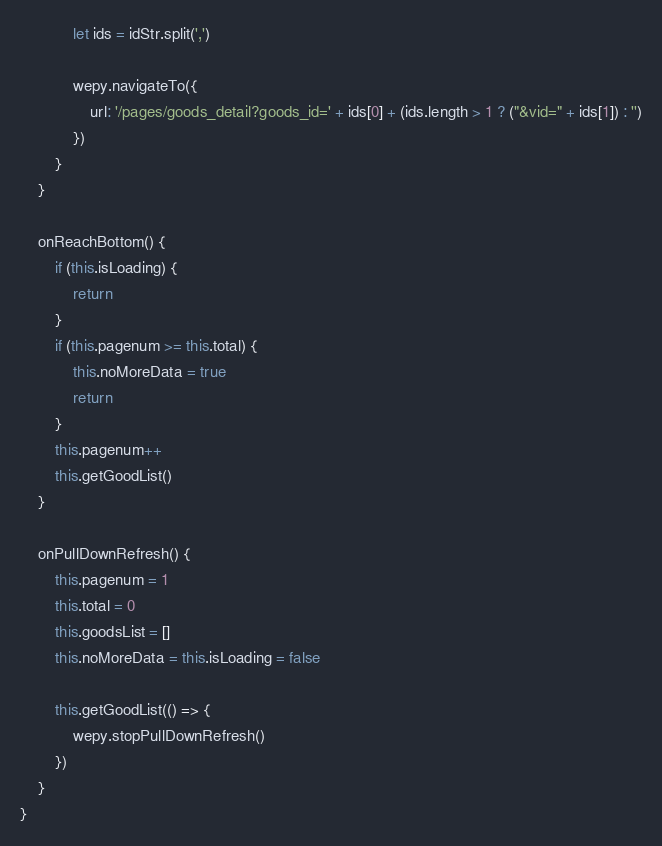Convert code to text. <code><loc_0><loc_0><loc_500><loc_500><_JavaScript_>            let ids = idStr.split(',')

            wepy.navigateTo({
                url: '/pages/goods_detail?goods_id=' + ids[0] + (ids.length > 1 ? ("&vid=" + ids[1]) : '')
            })
        }
    }

    onReachBottom() {
        if (this.isLoading) {
            return
        }
        if (this.pagenum >= this.total) {
            this.noMoreData = true
            return
        }
        this.pagenum++
        this.getGoodList()
    }

    onPullDownRefresh() {      
        this.pagenum = 1
        this.total = 0
        this.goodsList = []
        this.noMoreData = this.isLoading = false

        this.getGoodList(() => {
            wepy.stopPullDownRefresh()
        })
    }
}
</code> 